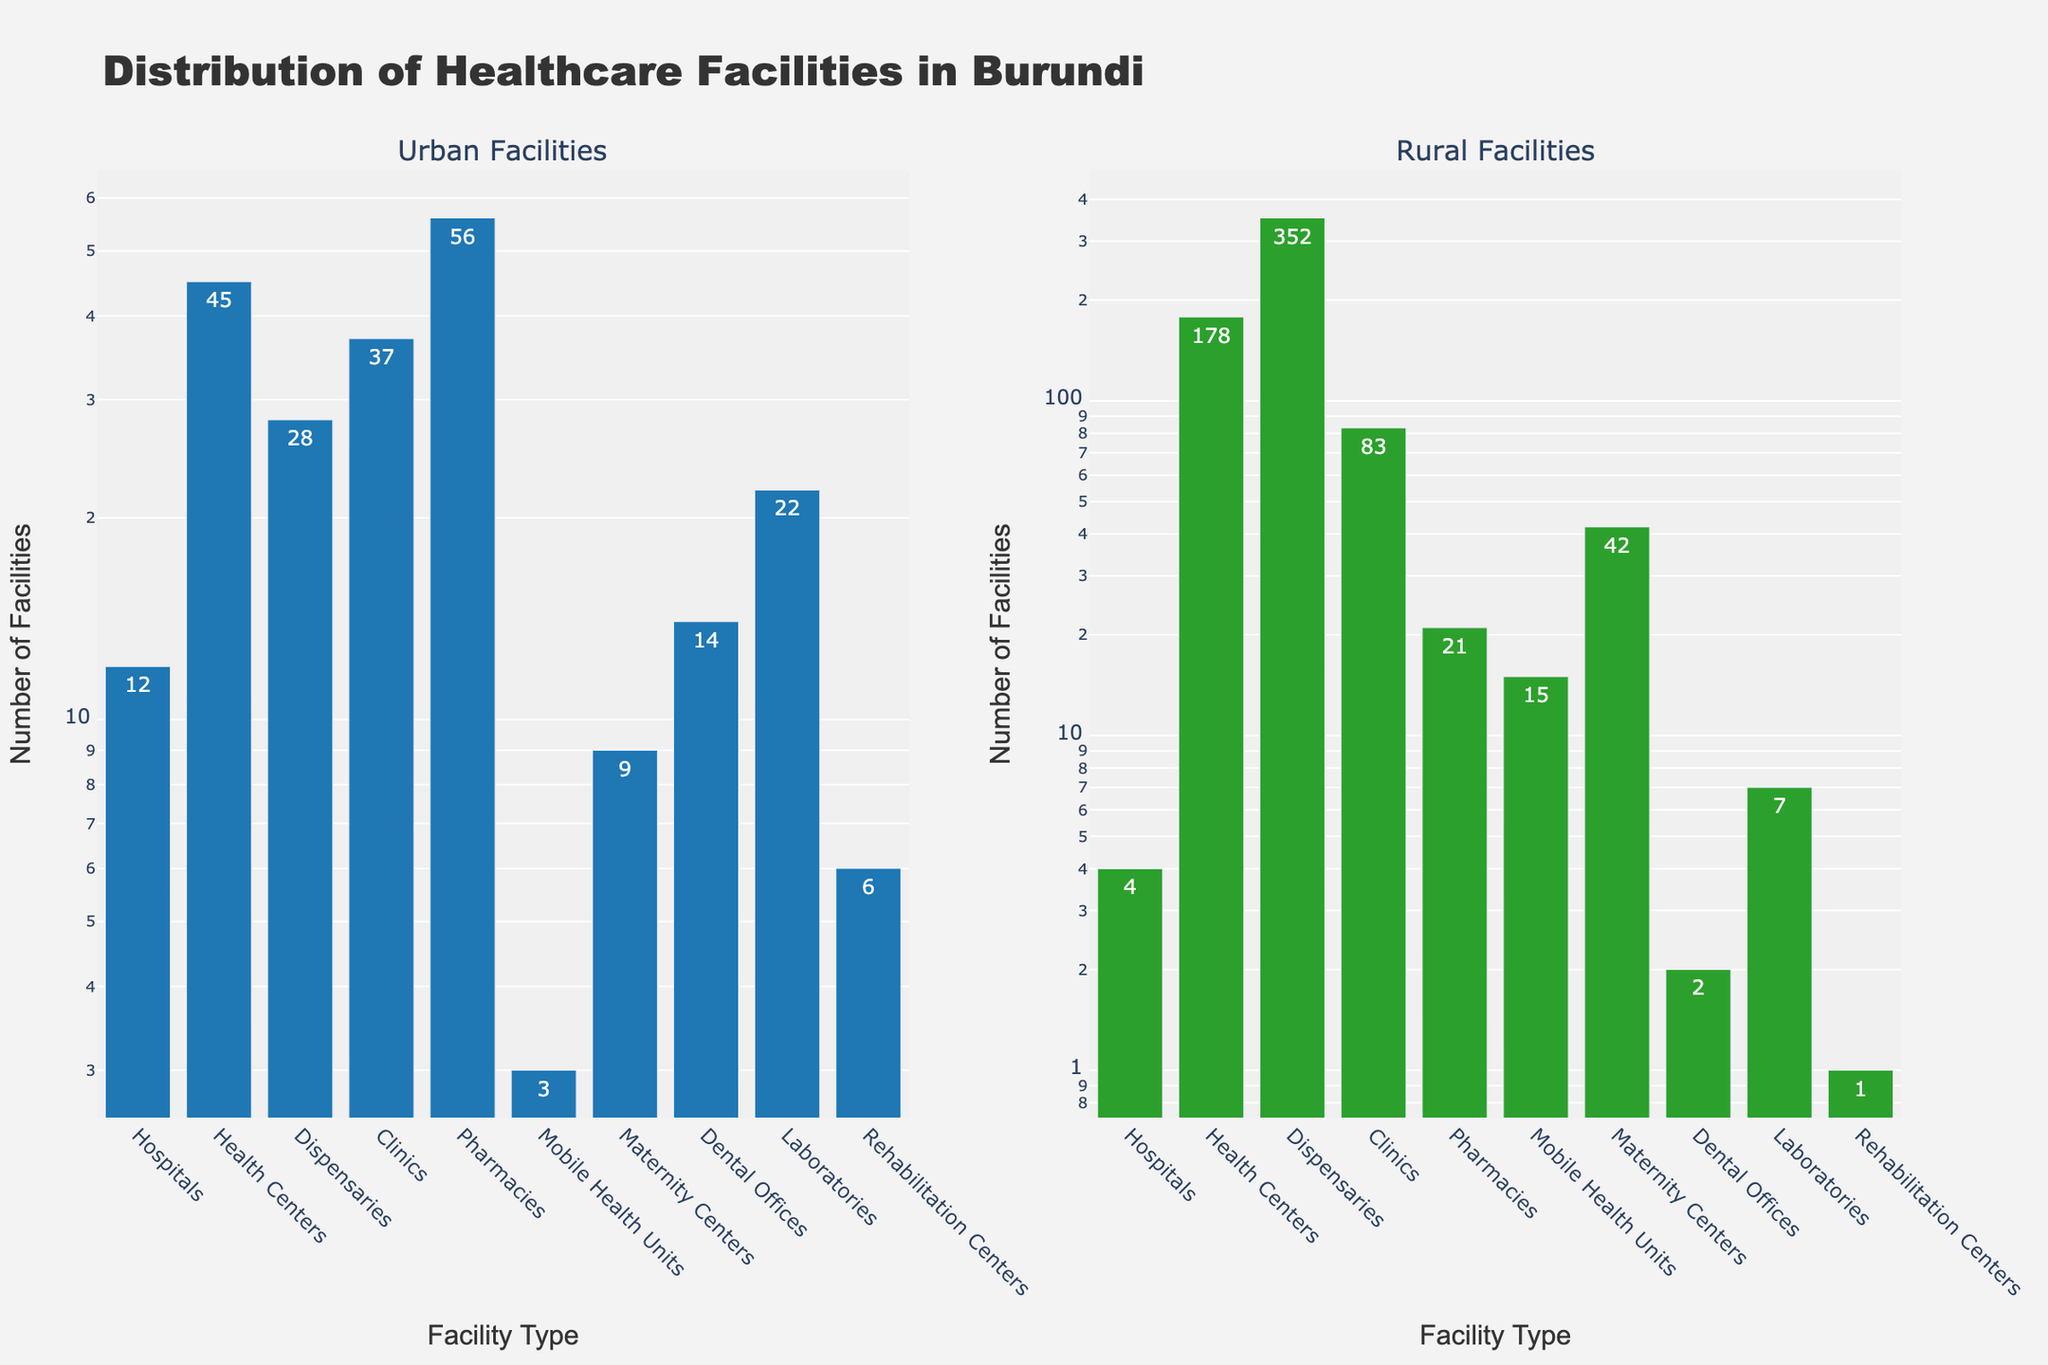What type of facility is the most common in urban areas? By observing the height of the bars in the Urban Facilities subplot, the tallest bar represents Pharmacies, indicating that they are the most common facility in urban areas.
Answer: Pharmacies Which facility type has the highest disparity in number between urban and rural areas? Compare the differences between the heights of corresponding bars in the Urban and Rural Facilities subplots. Dispensaries have a huge difference, with 28 in urban and 352 in rural areas, making it the type with the largest disparity.
Answer: Dispensaries How many total Clinics are there in both urban and rural areas combined? Add the number of Clinics in urban areas to those in rural areas (37 + 83).
Answer: 120 Which facility is only found in a significant number in urban areas but almost absent in rural areas? Look for a facility type with a tall bar in the Urban Facilities subplot but almost no bar in the Rural Facilities subplot. Dental Offices fit this description, with 14 in urban and only 2 in rural areas.
Answer: Dental Offices What is the ratio of Hospitals in urban areas to those in rural areas? Divide the number of Hospitals in urban areas by the number of Hospitals in rural areas (12 / 4).
Answer: 3 Are there more Health Centers or Pharmacies in rural areas? Observe the heights of the bars representing Health Centers and Pharmacies in the Rural Facilities subplot. The bar for Health Centers is significantly higher (178) compared to that for Pharmacies (21).
Answer: Health Centers What's the total number of all types of healthcare facilities in the rural areas? Sum the numbers of all facilities in rural areas: 4 + 178 + 352 + 83 + 21 + 15 + 42 + 2 + 7 + 1.
Answer: 705 Which facility type has the fewest number in urban areas? Look for the shortest bar in the Urban Facilities subplot. Mobile Health Units, with only 3 units, have the shortest bar.
Answer: Mobile Health Units Compare the number of Maternity Centers in urban areas to the number of Clinics in rural areas. Which is higher? Look at the Urban Facilities subplot for Maternity Centers (9) and the Rural Facilities subplot for Clinics (83). The number of Clinics in rural areas is higher.
Answer: Clinics in rural areas What is the total number of Dispensaries in Burundi? Add the number of Dispensaries in urban areas to those in rural areas (28 + 352).
Answer: 380 